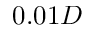<formula> <loc_0><loc_0><loc_500><loc_500>0 . 0 1 D</formula> 